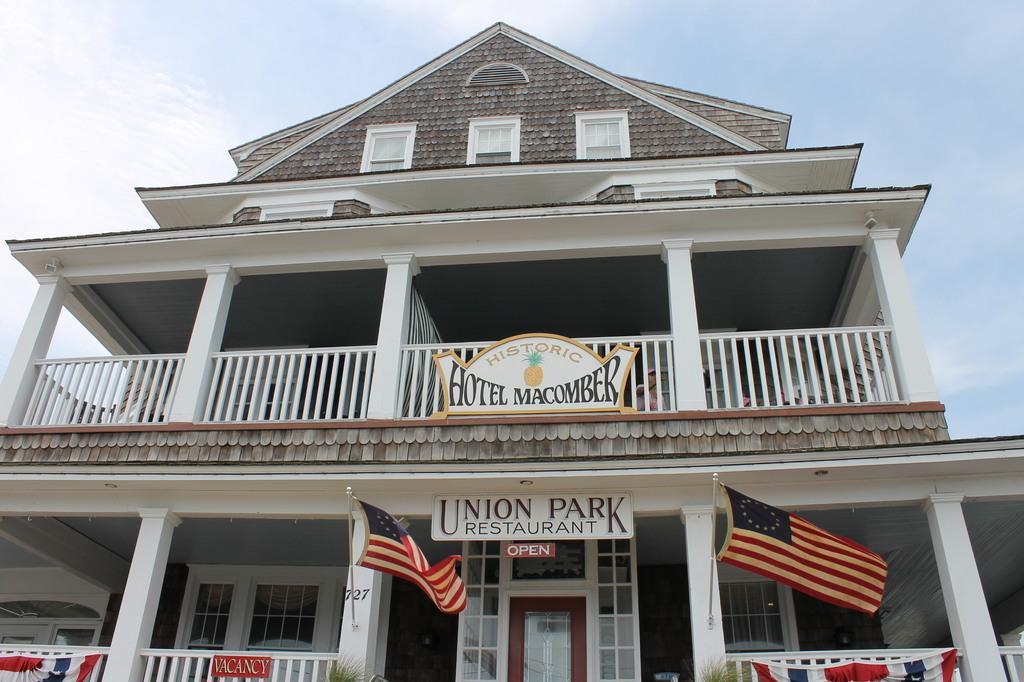What type of structure is present in the image? There is a building in the image. Are there any flags on the building? Yes, the building has 2 flags. How can someone enter the building? The building has a door. What is surrounding the building? The building has a white fence. Can you see inside the building through the image? Yes, the building has windows. Are there any signs or labels on the building? Yes, there are name boards in the image. What type of net is being used by the farmer in the image? There is no farmer or net present in the image; it features a building with flags, a door, a fence, windows, and name boards. 